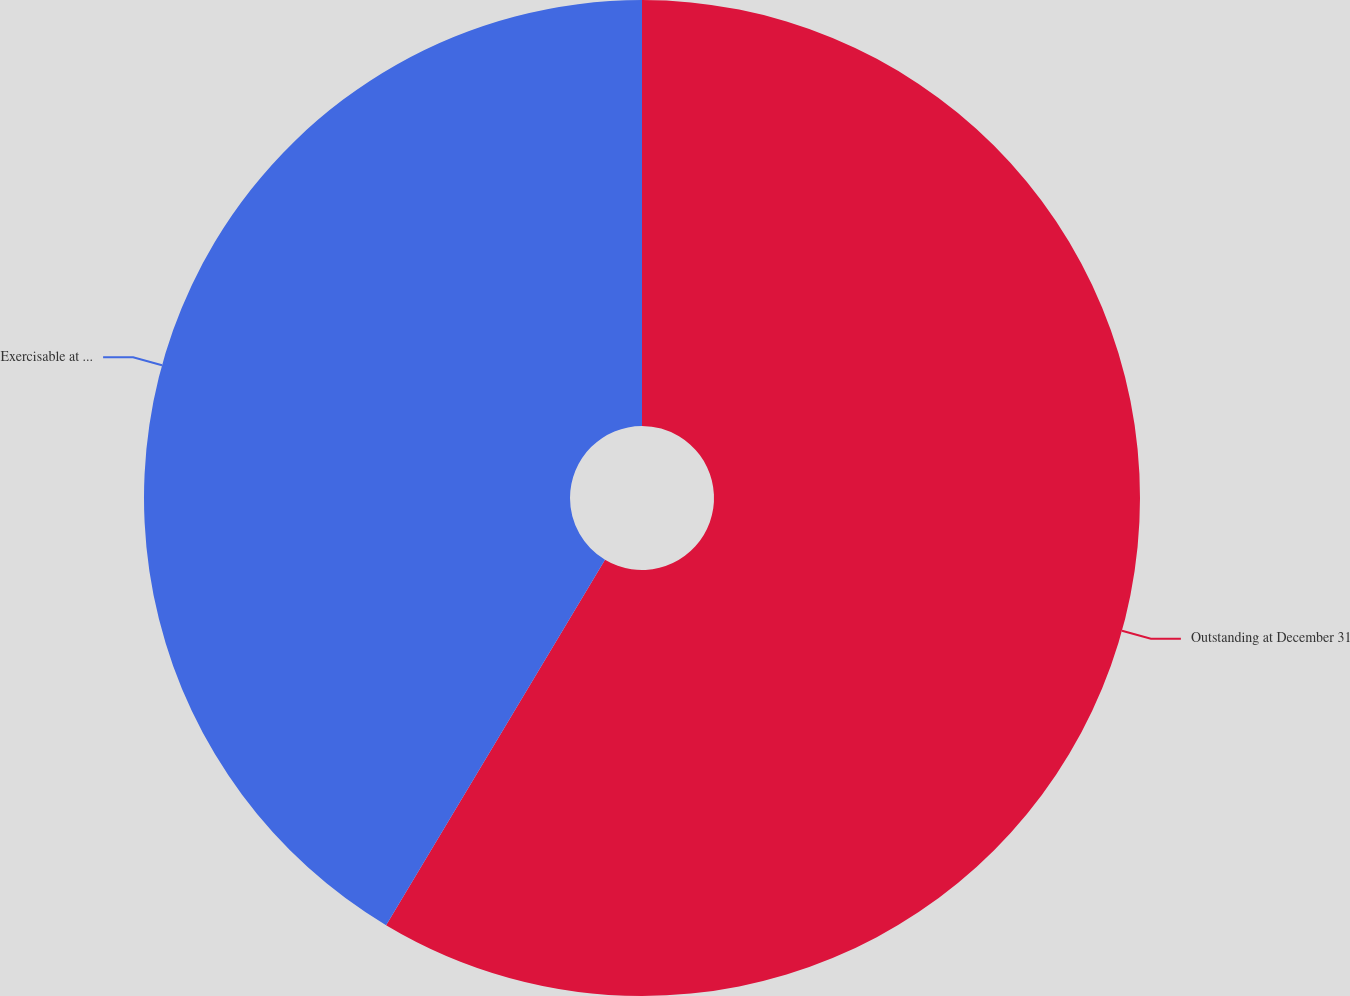<chart> <loc_0><loc_0><loc_500><loc_500><pie_chart><fcel>Outstanding at December 31<fcel>Exercisable at December 31<nl><fcel>58.59%<fcel>41.41%<nl></chart> 